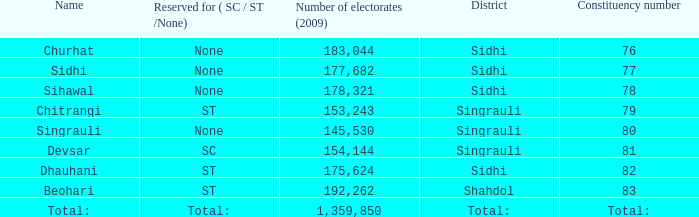What is the district with 79 constituency number? Singrauli. 